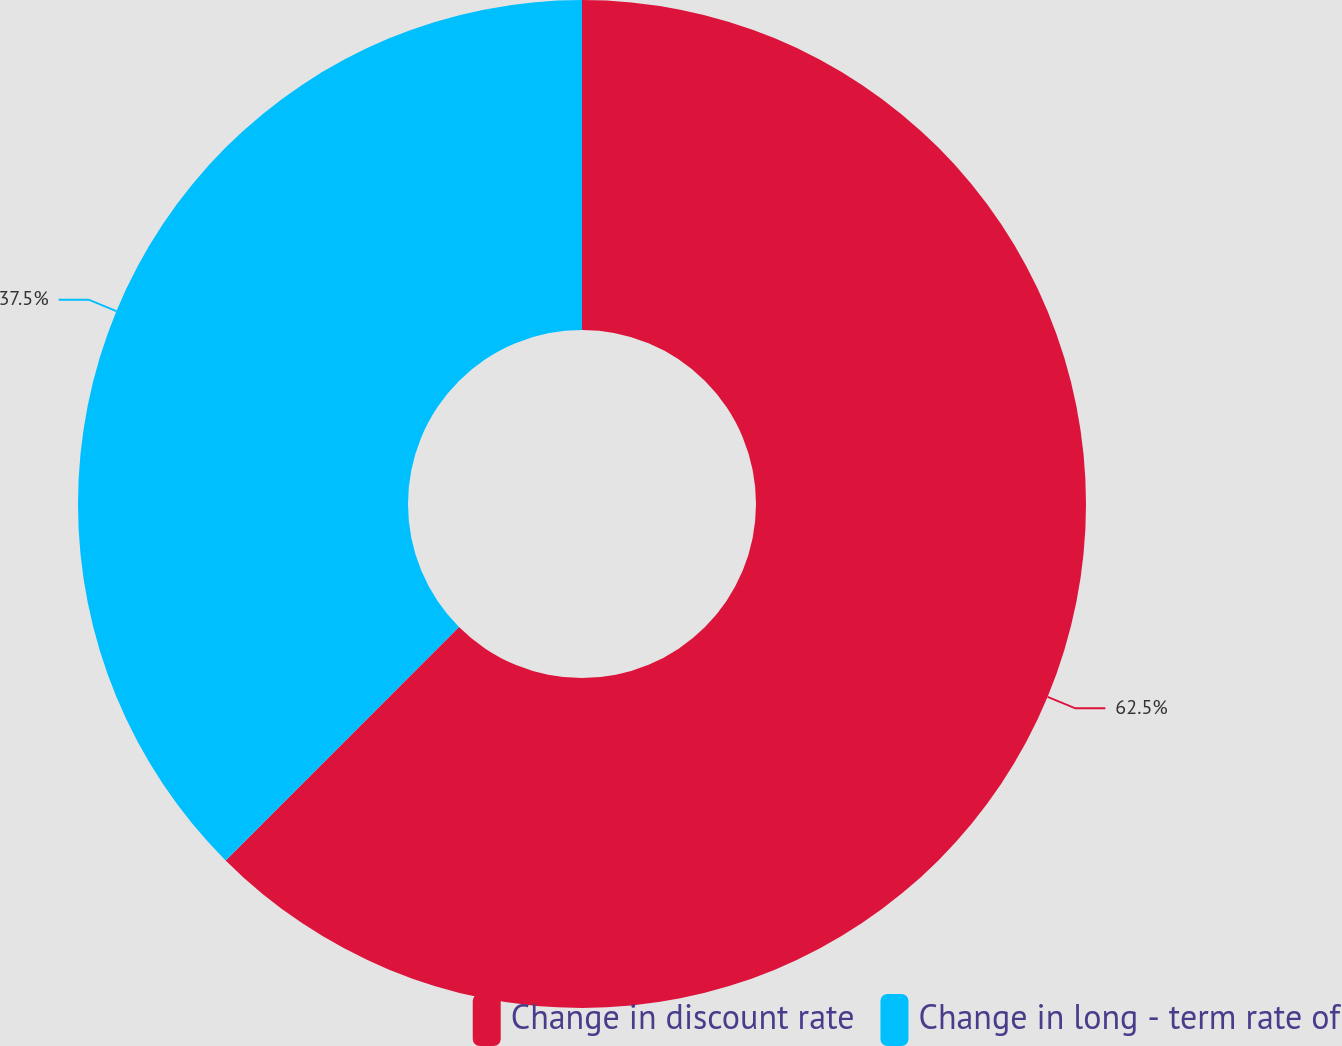Convert chart. <chart><loc_0><loc_0><loc_500><loc_500><pie_chart><fcel>Change in discount rate<fcel>Change in long - term rate of<nl><fcel>62.5%<fcel>37.5%<nl></chart> 